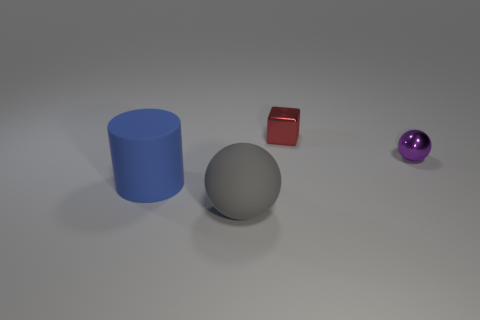How many things are big yellow shiny spheres or big objects on the left side of the rubber sphere?
Give a very brief answer. 1. What color is the thing behind the purple sphere?
Your answer should be very brief. Red. Do the ball that is left of the tiny red thing and the ball behind the matte ball have the same size?
Provide a short and direct response. No. Is there a red object of the same size as the blue matte cylinder?
Your response must be concise. No. There is a shiny object that is behind the tiny purple sphere; how many small purple things are in front of it?
Give a very brief answer. 1. What is the material of the big cylinder?
Make the answer very short. Rubber. How many tiny cubes are in front of the large sphere?
Your answer should be very brief. 0. Are there more cylinders than large brown objects?
Make the answer very short. Yes. There is a thing that is in front of the metal sphere and behind the big matte ball; what is its size?
Offer a terse response. Large. Does the ball right of the small block have the same material as the tiny object to the left of the purple sphere?
Give a very brief answer. Yes. 